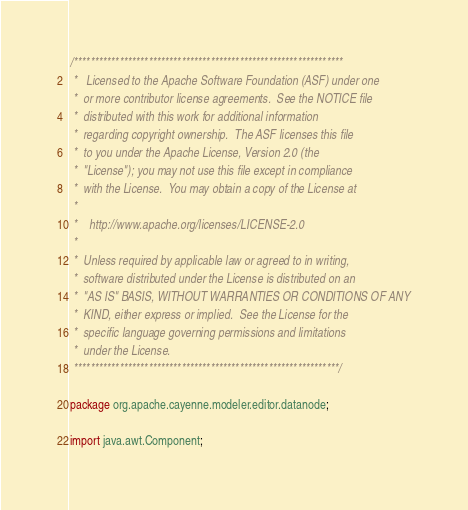Convert code to text. <code><loc_0><loc_0><loc_500><loc_500><_Java_>/*****************************************************************
 *   Licensed to the Apache Software Foundation (ASF) under one
 *  or more contributor license agreements.  See the NOTICE file
 *  distributed with this work for additional information
 *  regarding copyright ownership.  The ASF licenses this file
 *  to you under the Apache License, Version 2.0 (the
 *  "License"); you may not use this file except in compliance
 *  with the License.  You may obtain a copy of the License at
 *
 *    http://www.apache.org/licenses/LICENSE-2.0
 *
 *  Unless required by applicable law or agreed to in writing,
 *  software distributed under the License is distributed on an
 *  "AS IS" BASIS, WITHOUT WARRANTIES OR CONDITIONS OF ANY
 *  KIND, either express or implied.  See the License for the
 *  specific language governing permissions and limitations
 *  under the License.
 ****************************************************************/

package org.apache.cayenne.modeler.editor.datanode;

import java.awt.Component;
</code> 